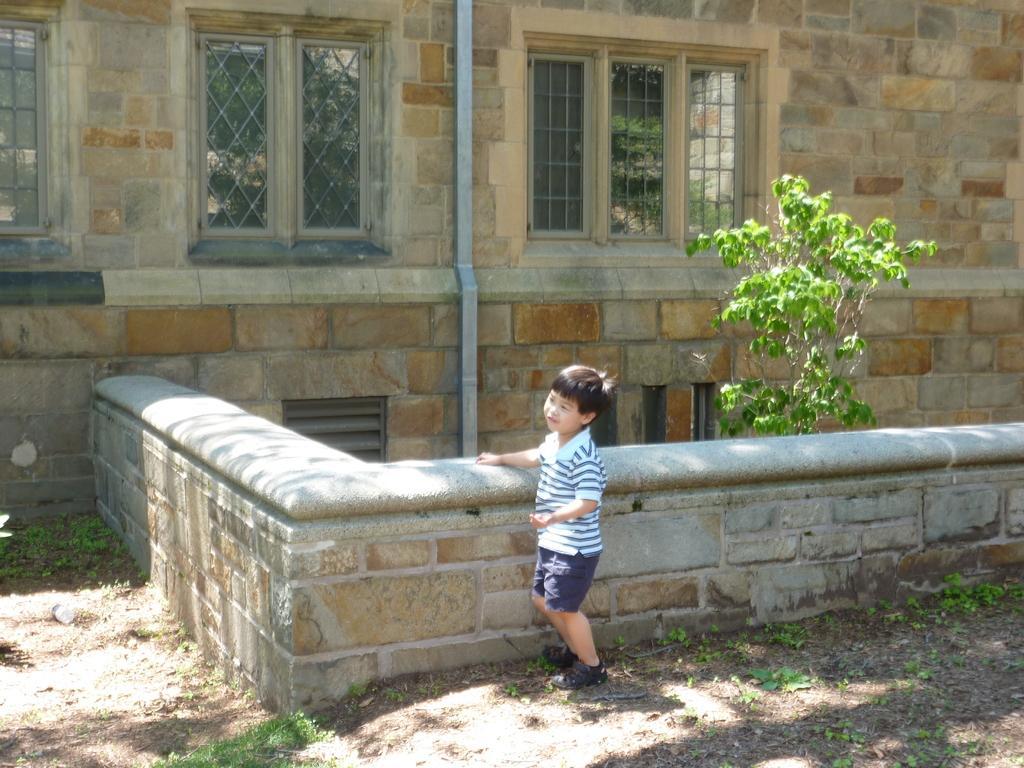How would you summarize this image in a sentence or two? In this picture, we can see a boy is standing on the path and behind the boy there is a wall, tree and building and to the building there are windows and a pipe. 